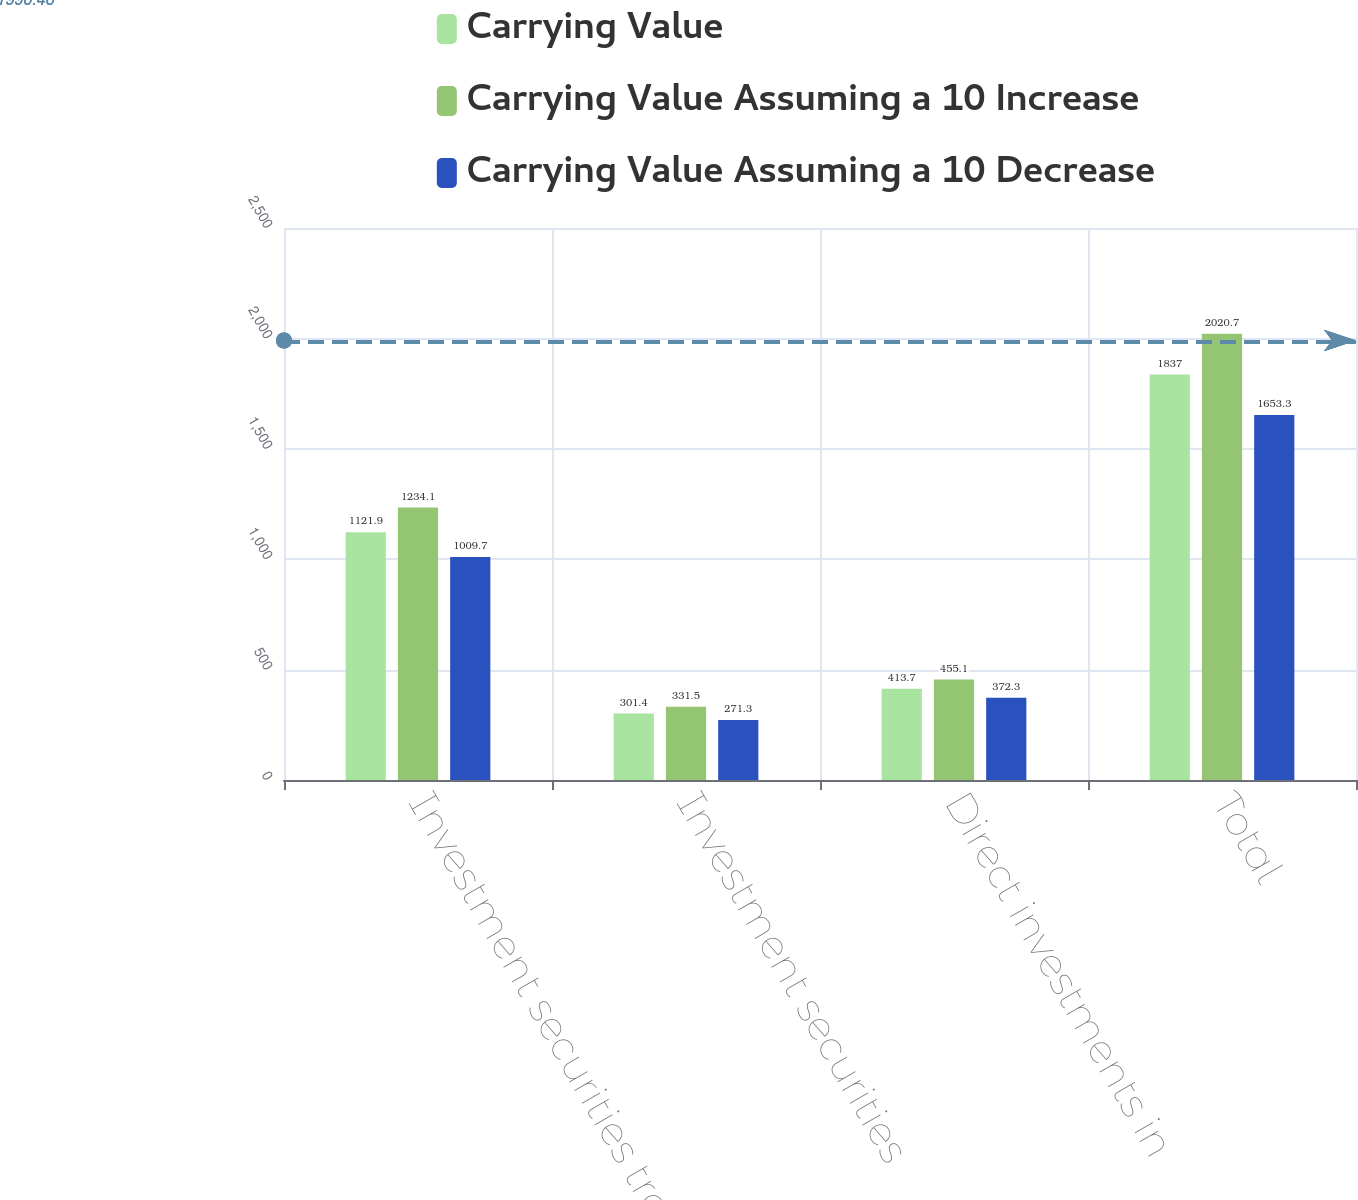Convert chart to OTSL. <chart><loc_0><loc_0><loc_500><loc_500><stacked_bar_chart><ecel><fcel>Investment securities trading<fcel>Investment securities<fcel>Direct investments in<fcel>Total<nl><fcel>Carrying Value<fcel>1121.9<fcel>301.4<fcel>413.7<fcel>1837<nl><fcel>Carrying Value Assuming a 10 Increase<fcel>1234.1<fcel>331.5<fcel>455.1<fcel>2020.7<nl><fcel>Carrying Value Assuming a 10 Decrease<fcel>1009.7<fcel>271.3<fcel>372.3<fcel>1653.3<nl></chart> 